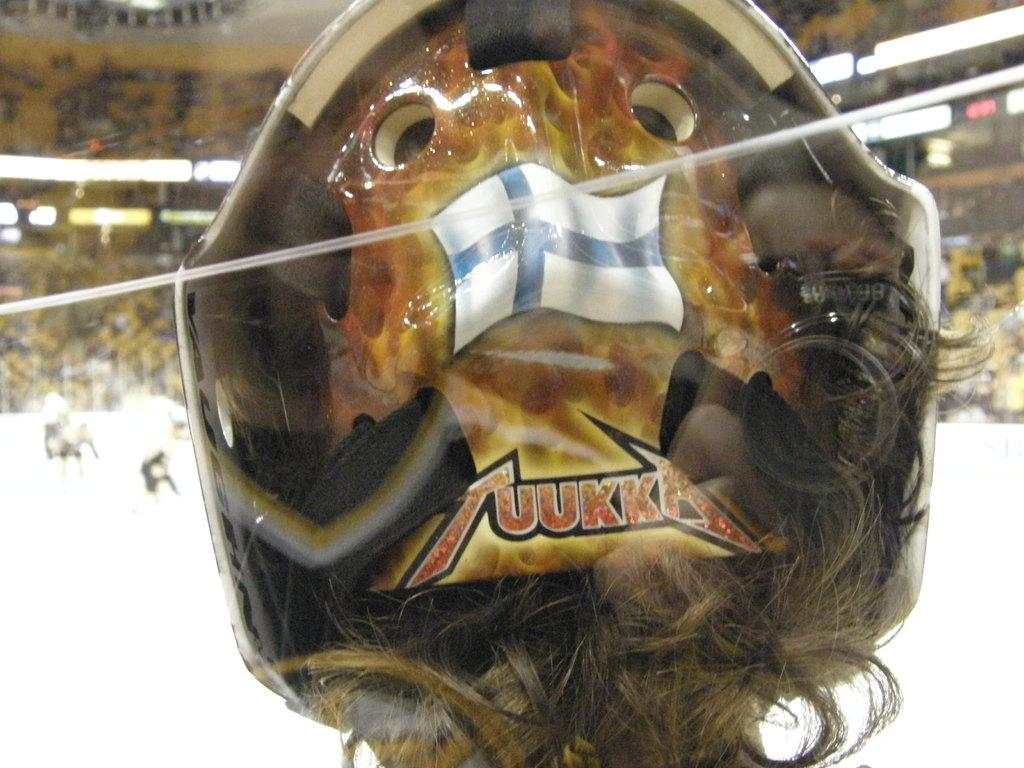What is the color of the object in the image? The object in the image has a brown color. Can you describe any features of the person in the image? A person's hair is visible in the image. How would you describe the background of the image? The background of the image is blurred. What value does the person in the image place on writing? There is no information about the person's values or writing in the image, so it cannot be determined from the image. 